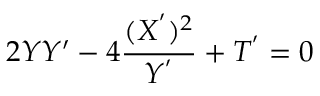Convert formula to latex. <formula><loc_0><loc_0><loc_500><loc_500>2 Y Y ^ { \prime } - 4 \frac { ( X ^ { ^ { \prime } } ) ^ { 2 } } { Y ^ { ^ { \prime } } } + T ^ { ^ { \prime } } = 0</formula> 